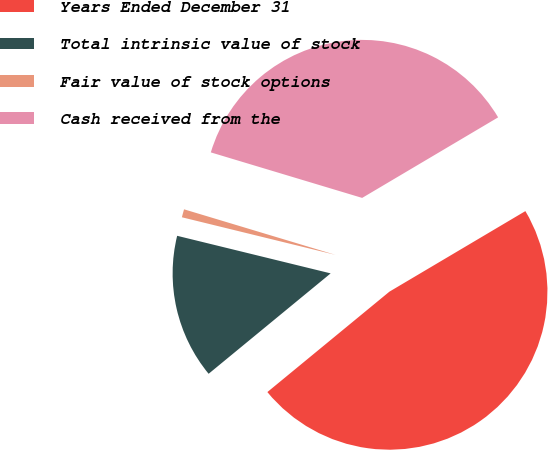Convert chart to OTSL. <chart><loc_0><loc_0><loc_500><loc_500><pie_chart><fcel>Years Ended December 31<fcel>Total intrinsic value of stock<fcel>Fair value of stock options<fcel>Cash received from the<nl><fcel>47.56%<fcel>14.78%<fcel>0.83%<fcel>36.84%<nl></chart> 